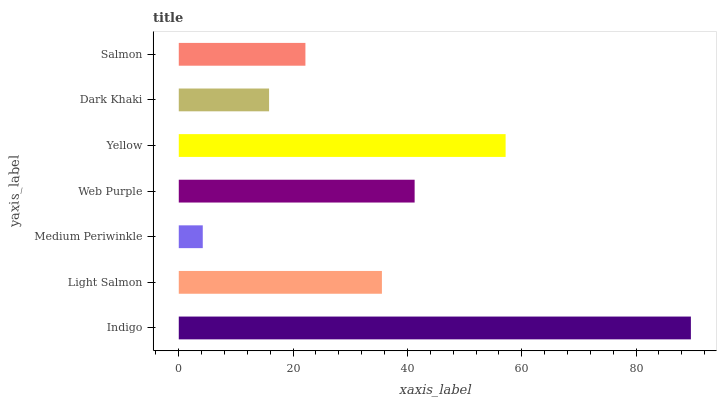Is Medium Periwinkle the minimum?
Answer yes or no. Yes. Is Indigo the maximum?
Answer yes or no. Yes. Is Light Salmon the minimum?
Answer yes or no. No. Is Light Salmon the maximum?
Answer yes or no. No. Is Indigo greater than Light Salmon?
Answer yes or no. Yes. Is Light Salmon less than Indigo?
Answer yes or no. Yes. Is Light Salmon greater than Indigo?
Answer yes or no. No. Is Indigo less than Light Salmon?
Answer yes or no. No. Is Light Salmon the high median?
Answer yes or no. Yes. Is Light Salmon the low median?
Answer yes or no. Yes. Is Indigo the high median?
Answer yes or no. No. Is Web Purple the low median?
Answer yes or no. No. 